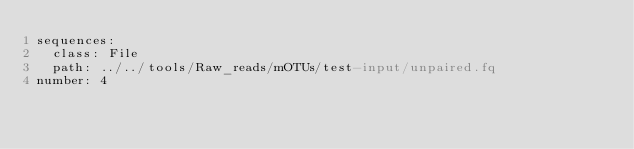<code> <loc_0><loc_0><loc_500><loc_500><_YAML_>sequences:
  class: File
  path: ../../tools/Raw_reads/mOTUs/test-input/unpaired.fq
number: 4</code> 